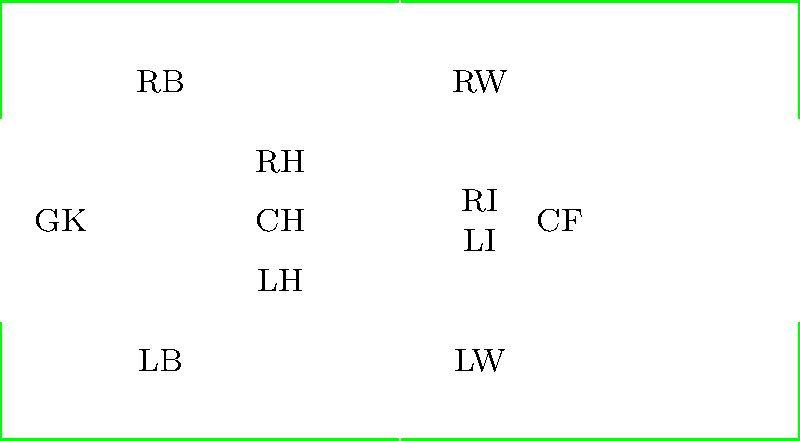As a field hockey coach, which player position would you recommend for a fast, agile player with excellent stick skills and the ability to create scoring opportunities? Justify your answer based on the diagram. To answer this question, let's consider the key aspects of field hockey positioning:

1. Field layout: The diagram shows a standard field hockey pitch with 11 player positions marked.

2. Player characteristics: The question describes a fast, agile player with excellent stick skills and the ability to create scoring opportunities.

3. Position requirements:
   - Forwards (LW, LI, CF, RI, RW) need speed, agility, and good stick skills to create and capitalize on scoring chances.
   - Midfielders (LH, CH, RH) require a balance of offensive and defensive skills.
   - Defenders (LB, RB) and the goalkeeper (GK) primarily focus on preventing goals.

4. Best fit: Given the player's attributes, they would be most effective in a forward position, particularly as a winger (LW or RW) or inside forward (LI or RI).

5. Optimal choice: The Right Wing (RW) position would be ideal because:
   - It utilizes the player's speed and agility for fast breaks and creating space.
   - Excellent stick skills are crucial for maintaining possession and making precise crosses.
   - The ability to create scoring opportunities is vital for a winger, who often assists in goals or scores themselves.
   - The RW position allows for both attacking play and the opportunity to fall back and support midfielders when needed.
Answer: Right Wing (RW) 